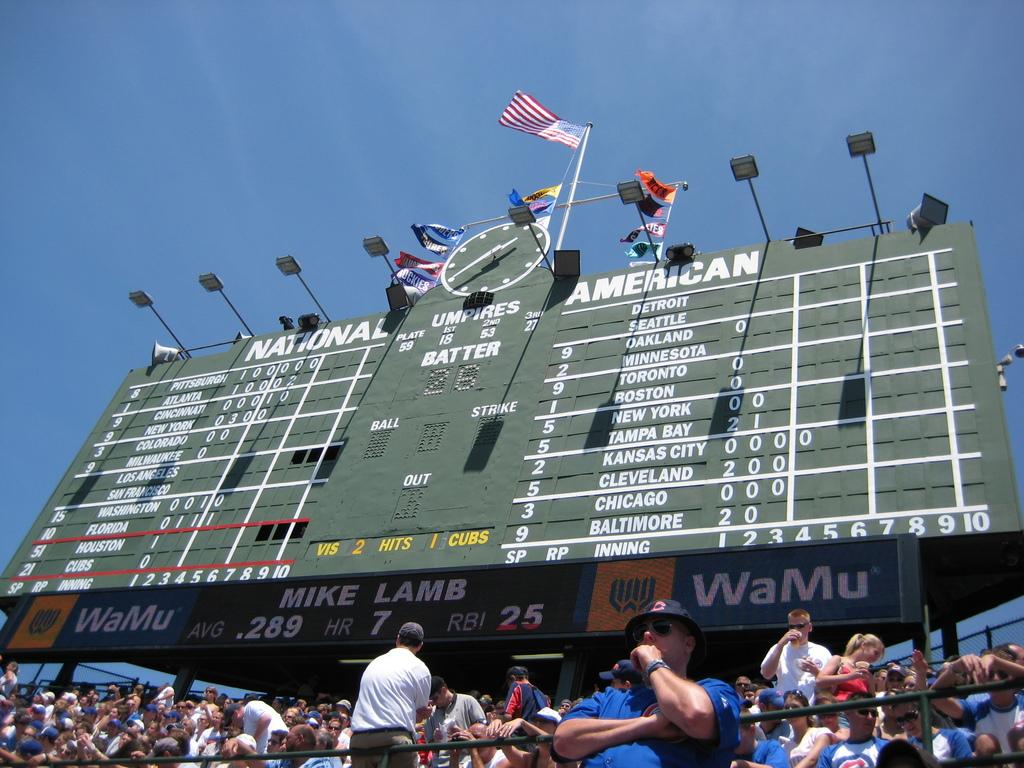<image>
Describe the image concisely. An old fashioned score board that is sponsored by WaMu. 